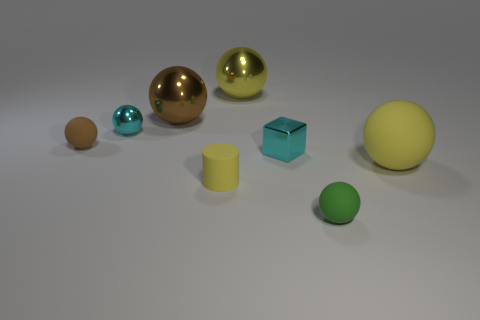Subtract all brown metal spheres. How many spheres are left? 5 Subtract all blue blocks. How many yellow spheres are left? 2 Subtract all brown spheres. How many spheres are left? 4 Add 1 green rubber objects. How many objects exist? 9 Subtract 4 spheres. How many spheres are left? 2 Subtract all purple spheres. Subtract all blue blocks. How many spheres are left? 6 Add 5 matte cylinders. How many matte cylinders exist? 6 Subtract 1 yellow cylinders. How many objects are left? 7 Subtract all cylinders. How many objects are left? 7 Subtract all green matte things. Subtract all small green matte things. How many objects are left? 6 